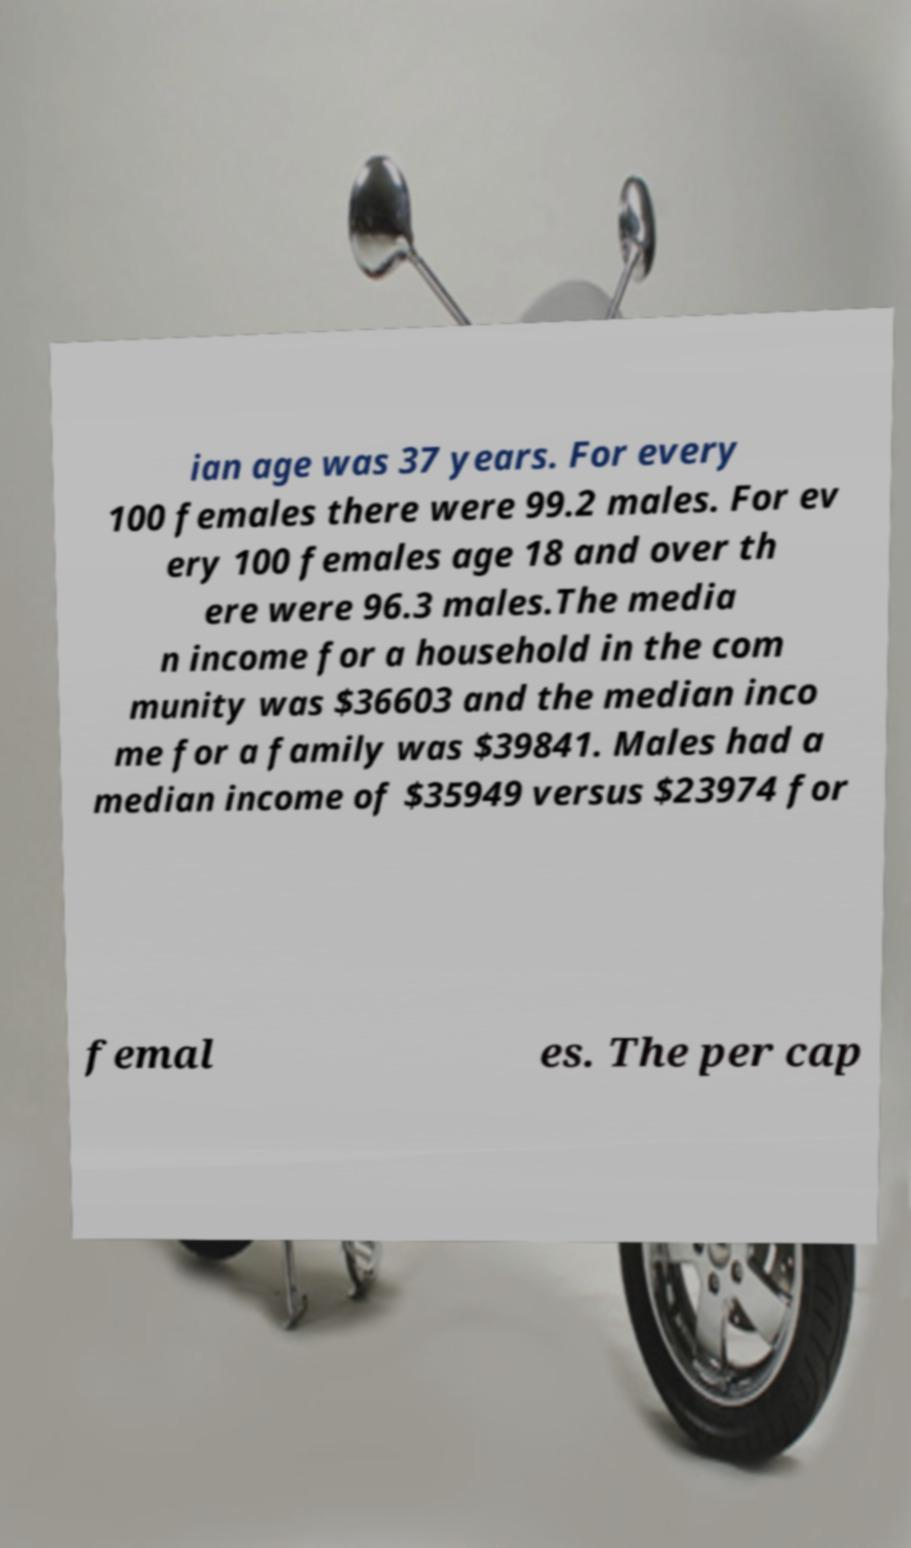Could you extract and type out the text from this image? ian age was 37 years. For every 100 females there were 99.2 males. For ev ery 100 females age 18 and over th ere were 96.3 males.The media n income for a household in the com munity was $36603 and the median inco me for a family was $39841. Males had a median income of $35949 versus $23974 for femal es. The per cap 